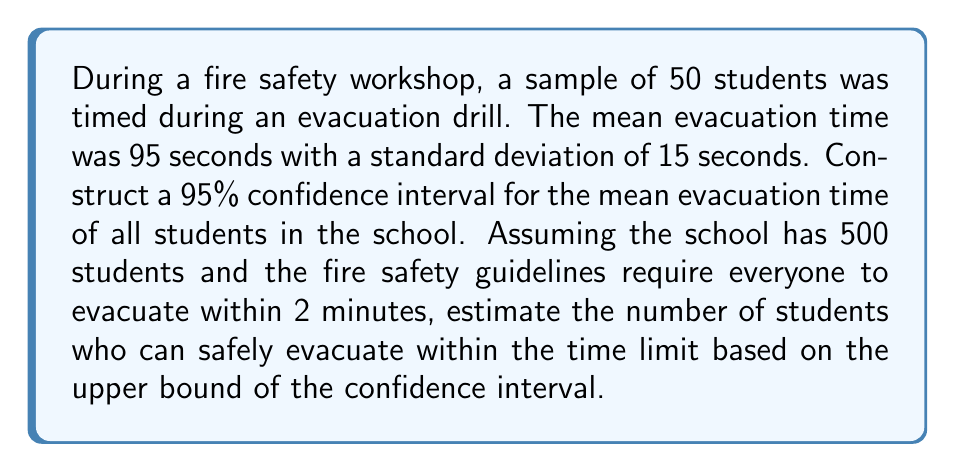Could you help me with this problem? 1. Calculate the standard error (SE) of the mean:
   $SE = \frac{s}{\sqrt{n}} = \frac{15}{\sqrt{50}} = 2.12$ seconds

2. Find the critical value for a 95% confidence level:
   For a 95% confidence level, use $z = 1.96$

3. Calculate the margin of error (ME):
   $ME = z \times SE = 1.96 \times 2.12 = 4.16$ seconds

4. Construct the 95% confidence interval:
   $CI = \bar{x} \pm ME = 95 \pm 4.16$
   Lower bound: $95 - 4.16 = 90.84$ seconds
   Upper bound: $95 + 4.16 = 99.16$ seconds

5. The upper bound of the confidence interval is 99.16 seconds, which is less than the 2-minute (120 seconds) requirement.

6. To estimate the number of students who can safely evacuate:
   $$\text{Number of students} = 500 \times \frac{120}{99.16} \approx 605$$

   This means that all 500 students can safely evacuate within the time limit based on the upper bound of the confidence interval.
Answer: All 500 students can safely evacuate within 2 minutes. 